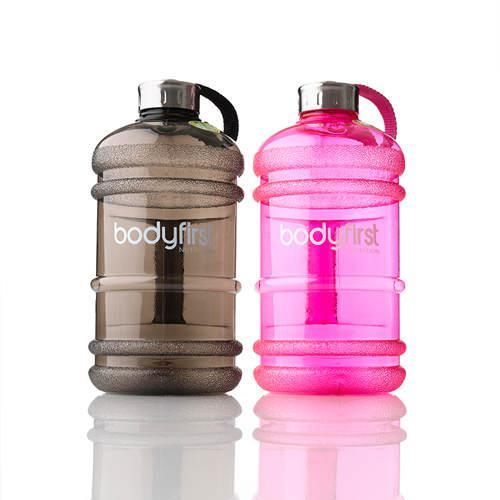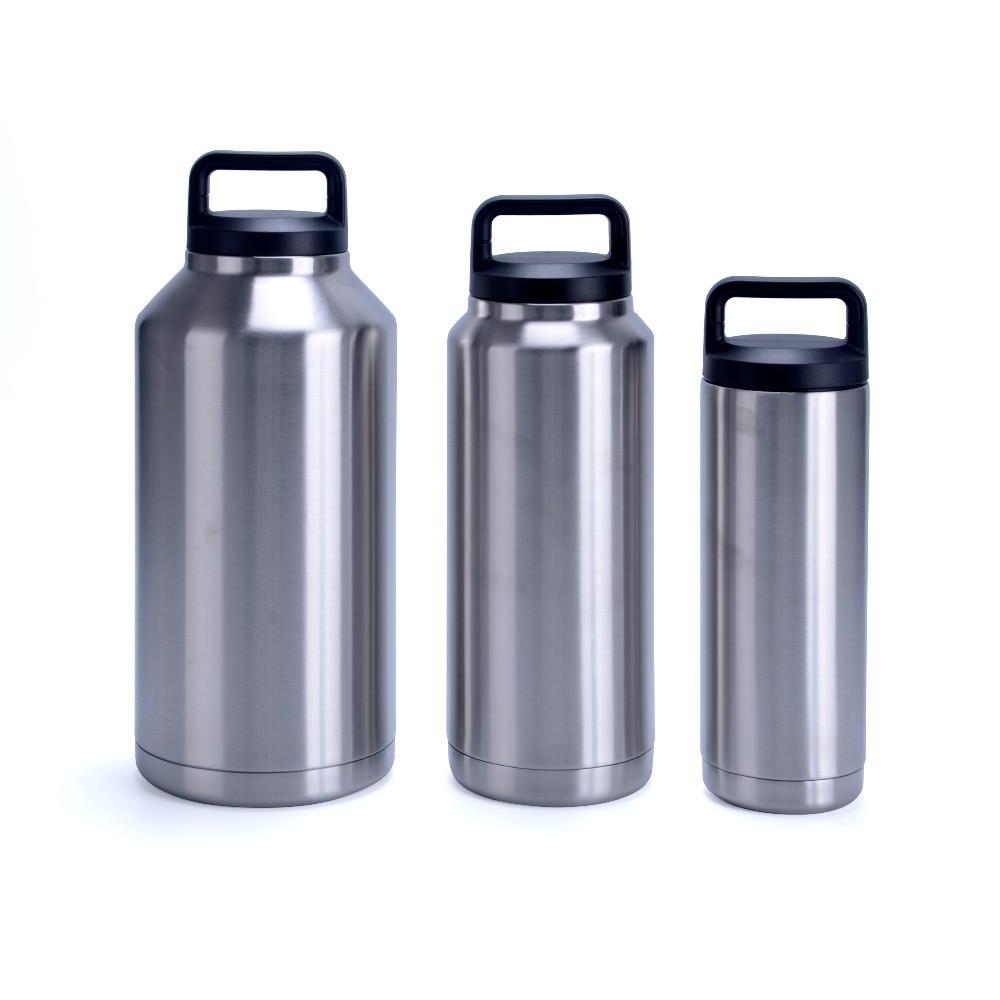The first image is the image on the left, the second image is the image on the right. Assess this claim about the two images: "The right image contains exactly three bottle containers arranged in a horizontal row.". Correct or not? Answer yes or no. Yes. The first image is the image on the left, the second image is the image on the right. Evaluate the accuracy of this statement regarding the images: "The left image includes two different-sized water bottles with blue caps that feature a side loop.". Is it true? Answer yes or no. No. 